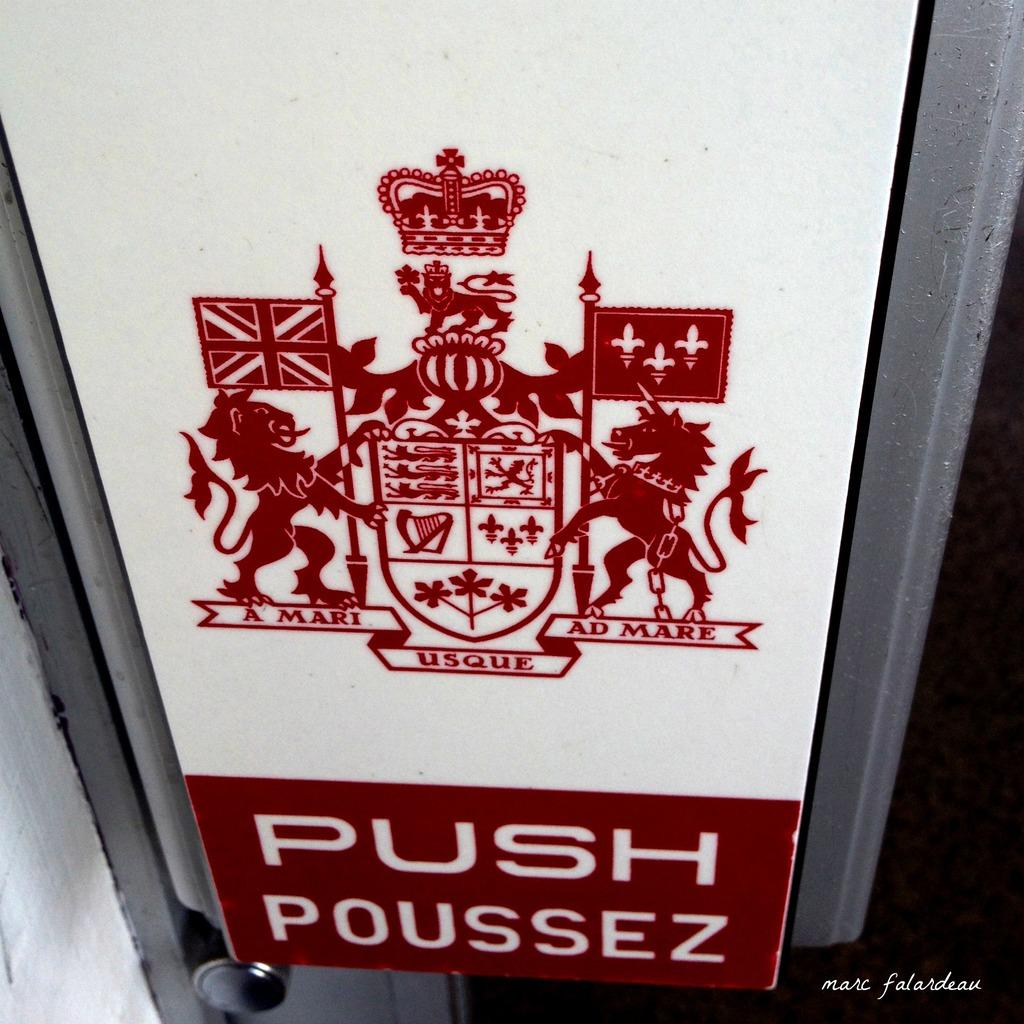<image>
Offer a succinct explanation of the picture presented. A coat of arms with flags and a crown and the push poussez underneath. 